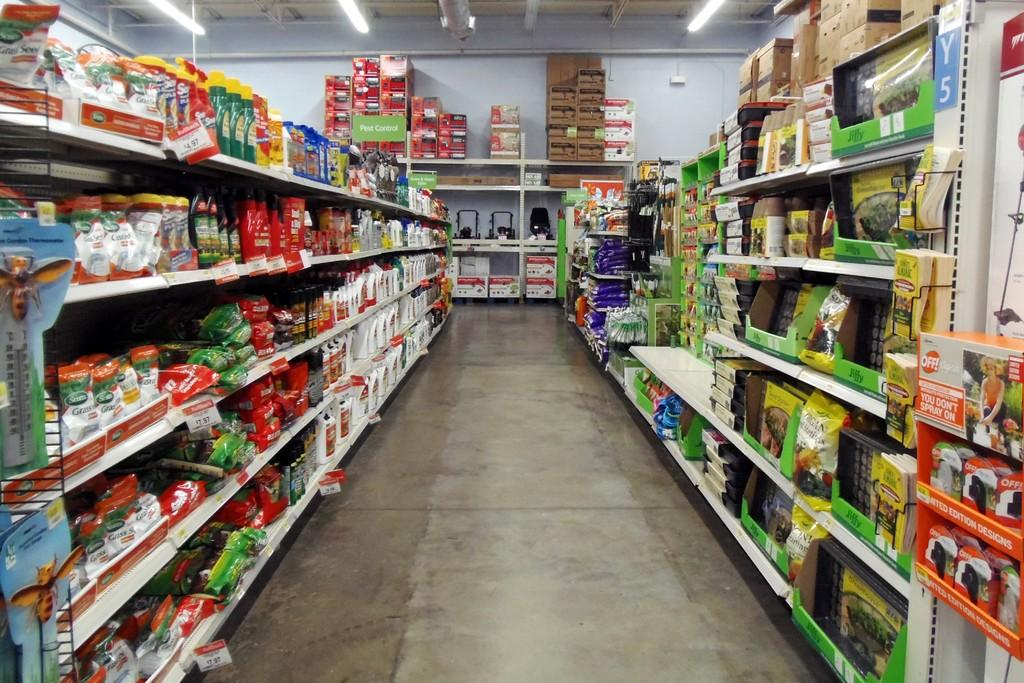<image>
Summarize the visual content of the image. a supermarket aisle with a tag reading 14.97. 